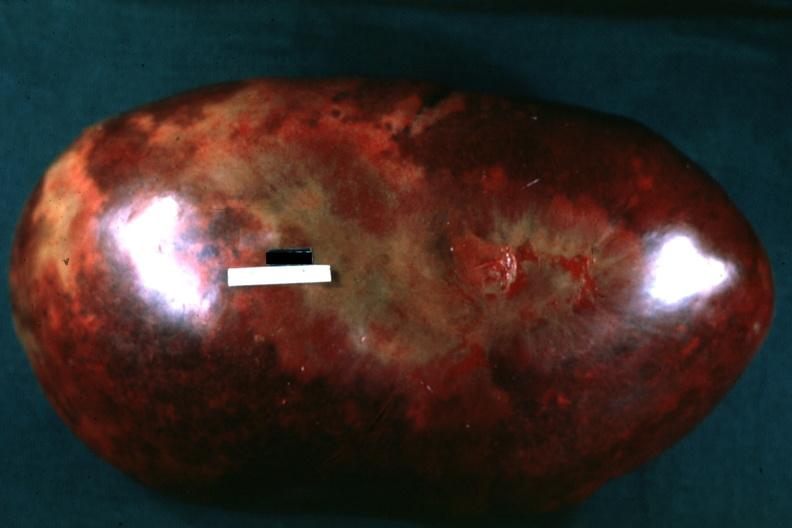s breast present?
Answer the question using a single word or phrase. No 